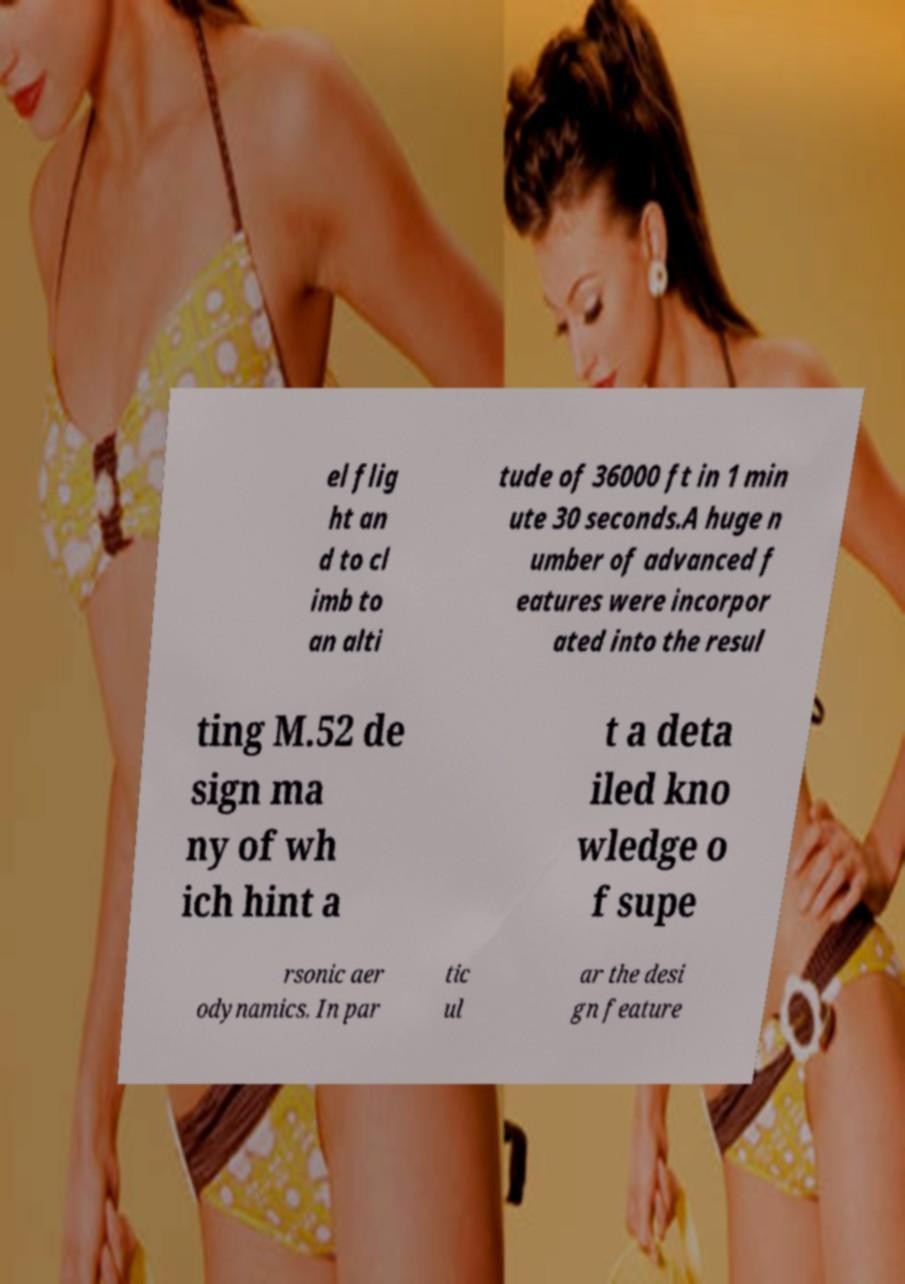Please identify and transcribe the text found in this image. el flig ht an d to cl imb to an alti tude of 36000 ft in 1 min ute 30 seconds.A huge n umber of advanced f eatures were incorpor ated into the resul ting M.52 de sign ma ny of wh ich hint a t a deta iled kno wledge o f supe rsonic aer odynamics. In par tic ul ar the desi gn feature 